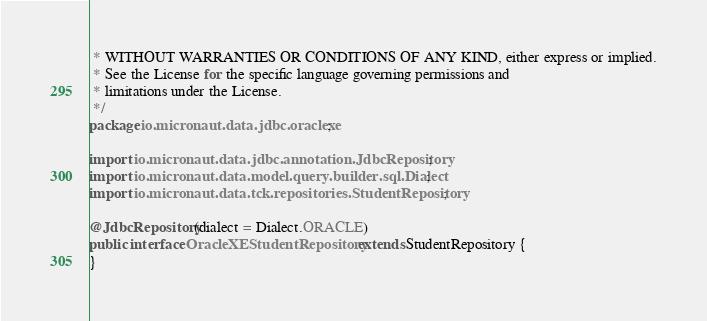<code> <loc_0><loc_0><loc_500><loc_500><_Java_> * WITHOUT WARRANTIES OR CONDITIONS OF ANY KIND, either express or implied.
 * See the License for the specific language governing permissions and
 * limitations under the License.
 */
package io.micronaut.data.jdbc.oraclexe;

import io.micronaut.data.jdbc.annotation.JdbcRepository;
import io.micronaut.data.model.query.builder.sql.Dialect;
import io.micronaut.data.tck.repositories.StudentRepository;

@JdbcRepository(dialect = Dialect.ORACLE)
public interface OracleXEStudentRepository extends StudentRepository {
}</code> 